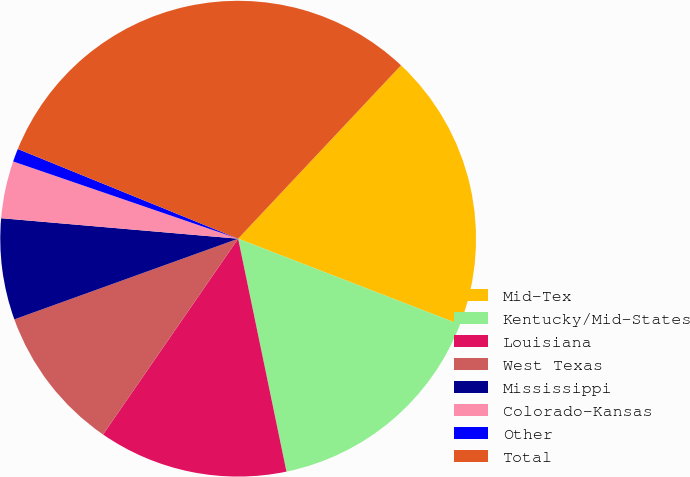Convert chart. <chart><loc_0><loc_0><loc_500><loc_500><pie_chart><fcel>Mid-Tex<fcel>Kentucky/Mid-States<fcel>Louisiana<fcel>West Texas<fcel>Mississippi<fcel>Colorado-Kansas<fcel>Other<fcel>Total<nl><fcel>18.87%<fcel>15.87%<fcel>12.87%<fcel>9.88%<fcel>6.88%<fcel>3.89%<fcel>0.89%<fcel>30.85%<nl></chart> 